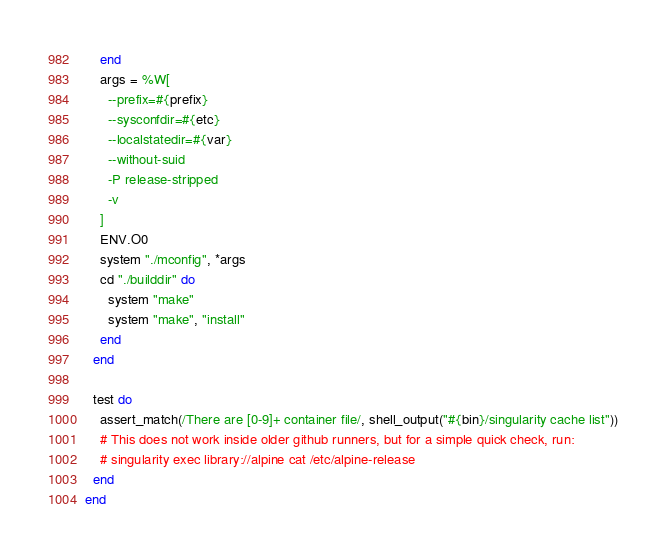Convert code to text. <code><loc_0><loc_0><loc_500><loc_500><_Ruby_>    end
    args = %W[
      --prefix=#{prefix}
      --sysconfdir=#{etc}
      --localstatedir=#{var}
      --without-suid
      -P release-stripped
      -v
    ]
    ENV.O0
    system "./mconfig", *args
    cd "./builddir" do
      system "make"
      system "make", "install"
    end
  end

  test do
    assert_match(/There are [0-9]+ container file/, shell_output("#{bin}/singularity cache list"))
    # This does not work inside older github runners, but for a simple quick check, run:
    # singularity exec library://alpine cat /etc/alpine-release
  end
end
</code> 